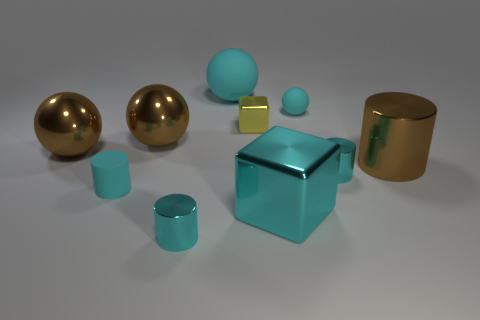What material is the big brown object that is to the right of the yellow object?
Provide a succinct answer. Metal. What material is the tiny ball?
Ensure brevity in your answer.  Rubber. There is a big sphere right of the tiny metallic object in front of the small cyan matte object in front of the big brown cylinder; what is its material?
Offer a very short reply. Rubber. There is a rubber cylinder; does it have the same size as the cyan metal cylinder left of the big cyan cube?
Your answer should be compact. Yes. What number of objects are either big cyan objects on the left side of the tiny yellow shiny thing or balls that are in front of the tiny cube?
Your answer should be compact. 3. There is a big metal thing to the right of the small cyan ball; what color is it?
Your response must be concise. Brown. Are there any tiny shiny cubes that are behind the small cyan thing that is behind the large brown metallic cylinder?
Your answer should be very brief. No. Is the number of tiny brown rubber blocks less than the number of big rubber objects?
Your answer should be compact. Yes. What is the material of the tiny cyan cylinder that is to the left of the tiny cyan shiny cylinder on the left side of the yellow metal thing?
Provide a succinct answer. Rubber. Does the yellow metal cube have the same size as the cyan matte cylinder?
Provide a short and direct response. Yes. 